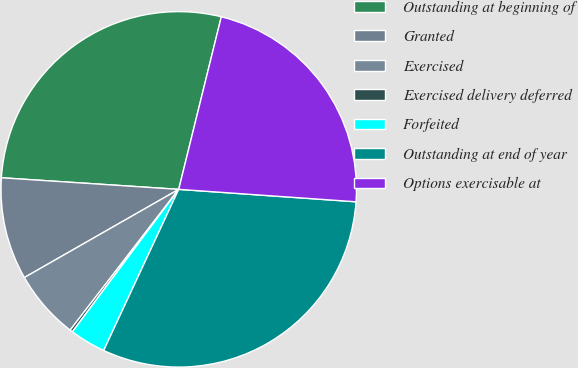<chart> <loc_0><loc_0><loc_500><loc_500><pie_chart><fcel>Outstanding at beginning of<fcel>Granted<fcel>Exercised<fcel>Exercised delivery deferred<fcel>Forfeited<fcel>Outstanding at end of year<fcel>Options exercisable at<nl><fcel>27.81%<fcel>9.3%<fcel>6.28%<fcel>0.25%<fcel>3.27%<fcel>30.82%<fcel>22.26%<nl></chart> 